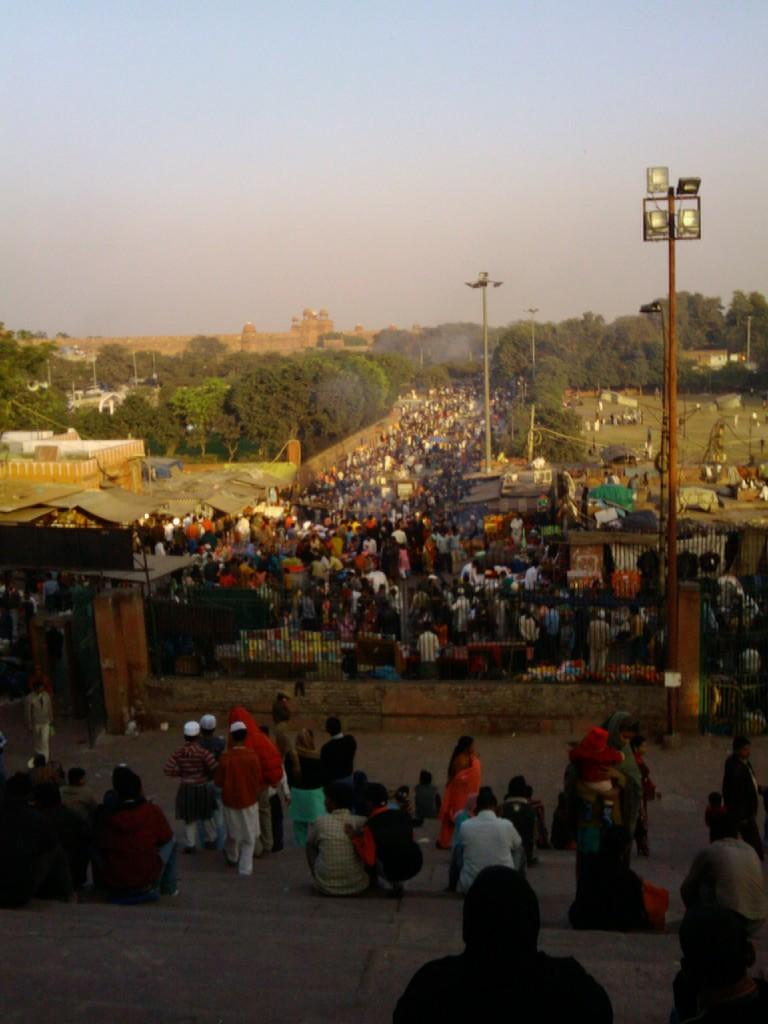What are the people in the middle of the image doing? The people in the middle of the image are walking and standing. What can be seen on either side of the people? There are trees on either side of the people. What is located in the background on the left side of the image? There is a building in the background on the left side of the image. What is visible above the building? The sky is visible above the building. What type of soap is being used by the people in the image? There is no soap present in the image; it features people walking and standing with trees, a building, and the sky visible. 